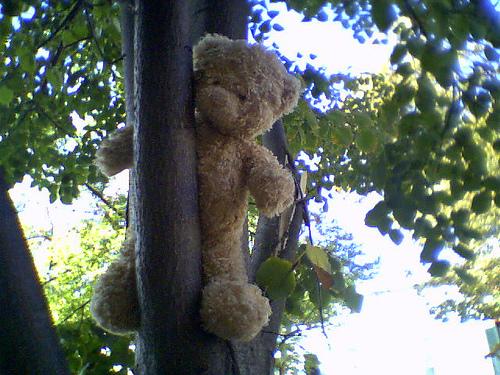Is this a stuffed monkey in the tree?
Write a very short answer. No. What is in the tree?
Be succinct. Teddy bear. Is the animal in the tree real?
Be succinct. No. 